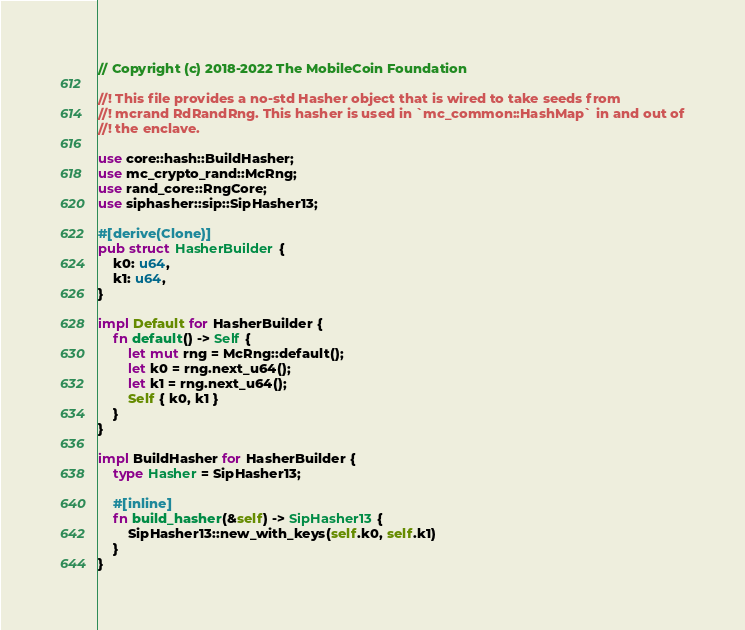<code> <loc_0><loc_0><loc_500><loc_500><_Rust_>// Copyright (c) 2018-2022 The MobileCoin Foundation

//! This file provides a no-std Hasher object that is wired to take seeds from
//! mcrand RdRandRng. This hasher is used in `mc_common::HashMap` in and out of
//! the enclave.

use core::hash::BuildHasher;
use mc_crypto_rand::McRng;
use rand_core::RngCore;
use siphasher::sip::SipHasher13;

#[derive(Clone)]
pub struct HasherBuilder {
    k0: u64,
    k1: u64,
}

impl Default for HasherBuilder {
    fn default() -> Self {
        let mut rng = McRng::default();
        let k0 = rng.next_u64();
        let k1 = rng.next_u64();
        Self { k0, k1 }
    }
}

impl BuildHasher for HasherBuilder {
    type Hasher = SipHasher13;

    #[inline]
    fn build_hasher(&self) -> SipHasher13 {
        SipHasher13::new_with_keys(self.k0, self.k1)
    }
}
</code> 